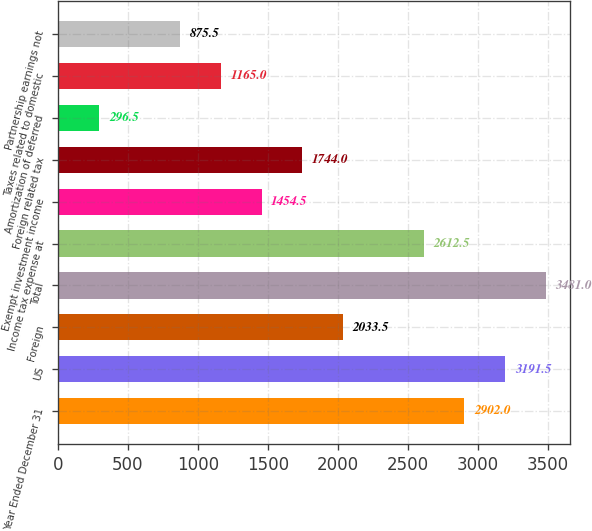Convert chart to OTSL. <chart><loc_0><loc_0><loc_500><loc_500><bar_chart><fcel>Year Ended December 31<fcel>US<fcel>Foreign<fcel>Total<fcel>Income tax expense at<fcel>Exempt investment income<fcel>Foreign related tax<fcel>Amortization of deferred<fcel>Taxes related to domestic<fcel>Partnership earnings not<nl><fcel>2902<fcel>3191.5<fcel>2033.5<fcel>3481<fcel>2612.5<fcel>1454.5<fcel>1744<fcel>296.5<fcel>1165<fcel>875.5<nl></chart> 